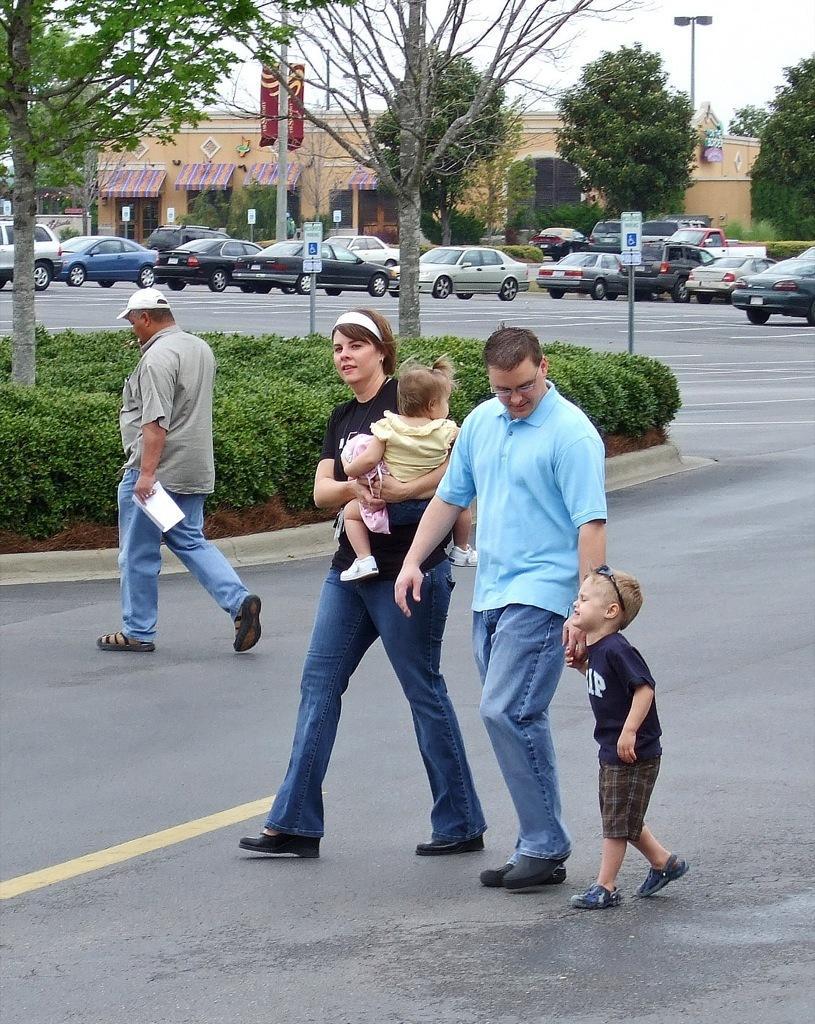Could you give a brief overview of what you see in this image? In this image I can see few people are walking and one person is holding baby. Back I can see few trees, poles, light pole, flag, sign boards, vehicles, buildings. The sky is in white color. 